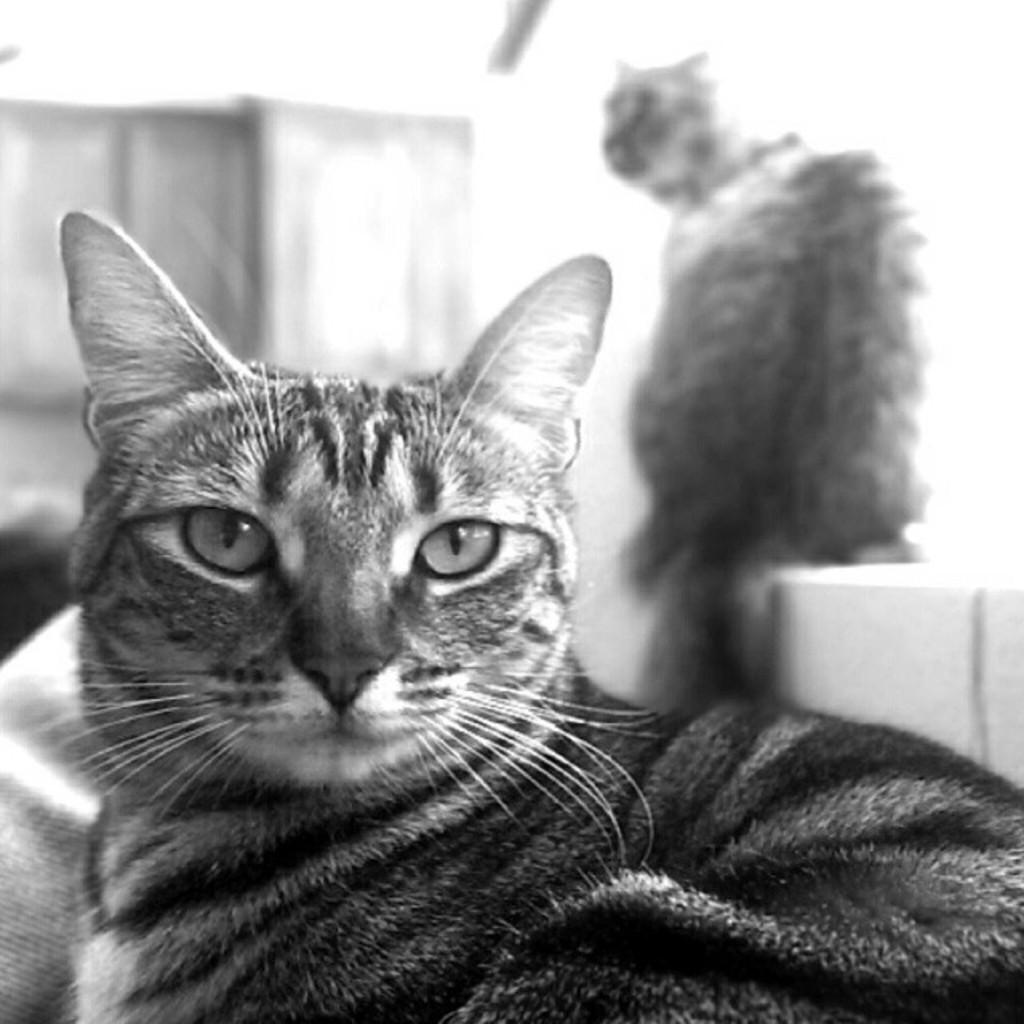What type of animal is present in the image? There is a cat in the image. What is the cat in the image doing? The cat is looking at the camera. Are there any other cats in the image? Yes, there is another cat in the image. Where is the second cat located? The second cat is on the wall. What is the color scheme of the image? The image is in black and white. What type of linen is being used to cover the cat on the wall? There is no linen present in the image, and the second cat is not covered by any fabric. 